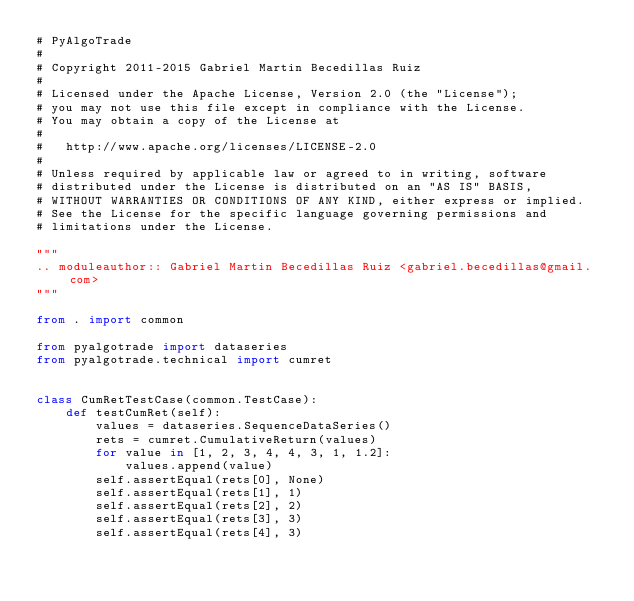<code> <loc_0><loc_0><loc_500><loc_500><_Python_># PyAlgoTrade
#
# Copyright 2011-2015 Gabriel Martin Becedillas Ruiz
#
# Licensed under the Apache License, Version 2.0 (the "License");
# you may not use this file except in compliance with the License.
# You may obtain a copy of the License at
#
#   http://www.apache.org/licenses/LICENSE-2.0
#
# Unless required by applicable law or agreed to in writing, software
# distributed under the License is distributed on an "AS IS" BASIS,
# WITHOUT WARRANTIES OR CONDITIONS OF ANY KIND, either express or implied.
# See the License for the specific language governing permissions and
# limitations under the License.

"""
.. moduleauthor:: Gabriel Martin Becedillas Ruiz <gabriel.becedillas@gmail.com>
"""

from . import common

from pyalgotrade import dataseries
from pyalgotrade.technical import cumret


class CumRetTestCase(common.TestCase):
    def testCumRet(self):
        values = dataseries.SequenceDataSeries()
        rets = cumret.CumulativeReturn(values)
        for value in [1, 2, 3, 4, 4, 3, 1, 1.2]:
            values.append(value)
        self.assertEqual(rets[0], None)
        self.assertEqual(rets[1], 1)
        self.assertEqual(rets[2], 2)
        self.assertEqual(rets[3], 3)
        self.assertEqual(rets[4], 3)</code> 